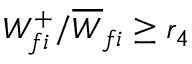<formula> <loc_0><loc_0><loc_500><loc_500>W _ { f i } ^ { + } / \overline { W } _ { f i } \geq r _ { 4 }</formula> 